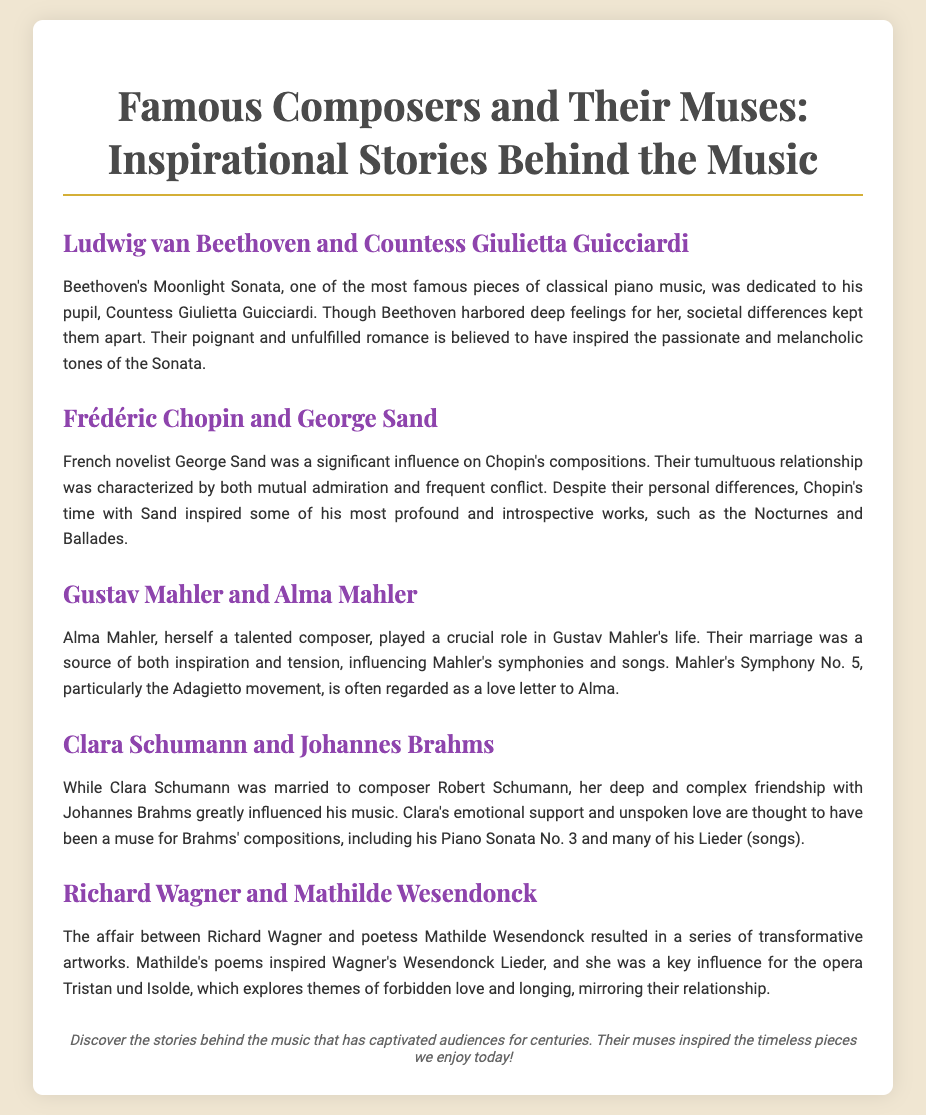What is the title of the poster? The title of the poster is presented prominently at the top, which is "Famous Composers and Their Muses: Inspirational Stories Behind the Music."
Answer: Famous Composers and Their Muses: Inspirational Stories Behind the Music Who is Beethoven's muse mentioned in the poster? The document specifies that Countess Giulietta Guicciardi is Beethoven's muse, associated with his Moonlight Sonata.
Answer: Countess Giulietta Guicciardi Which two composers had a relationship that inspired significant works by Chopin? The document indicates that Chopin's compositions were significantly influenced by George Sand, with whom he had a tumultuous relationship.
Answer: George Sand What is the name of Mahler's movement considered a love letter to Alma? The poster states that the Adagietto movement from Mahler's Symphony No. 5 is regarded as a love letter to Alma.
Answer: Adagietto Which opera was inspired by the affair between Wagner and Mathilde Wesendonck? The document mentions that the opera Tristan und Isolde was influenced by Wagner's relationship with Mathilde Wesendonck.
Answer: Tristan und Isolde What type of relationship did Brahms and Clara Schumann share? The document describes the relationship between Brahms and Clara Schumann as a deep and complex friendship, which greatly influenced Brahms’ music.
Answer: Deep and complex friendship How many sections are there in the document? The poster has a total of five sections, each highlighting different composers and their muses.
Answer: Five What theme is explored in Wagner's inspired opera? According to the document, Wagner's opera Tristan und Isolde explores themes of forbidden love and longing.
Answer: Forbidden love and longing What genre does Mahler’s wife, Alma, belong to? The document states that Alma Mahler was herself a talented composer, indicating her involvement in the same genre of music.
Answer: Composer 